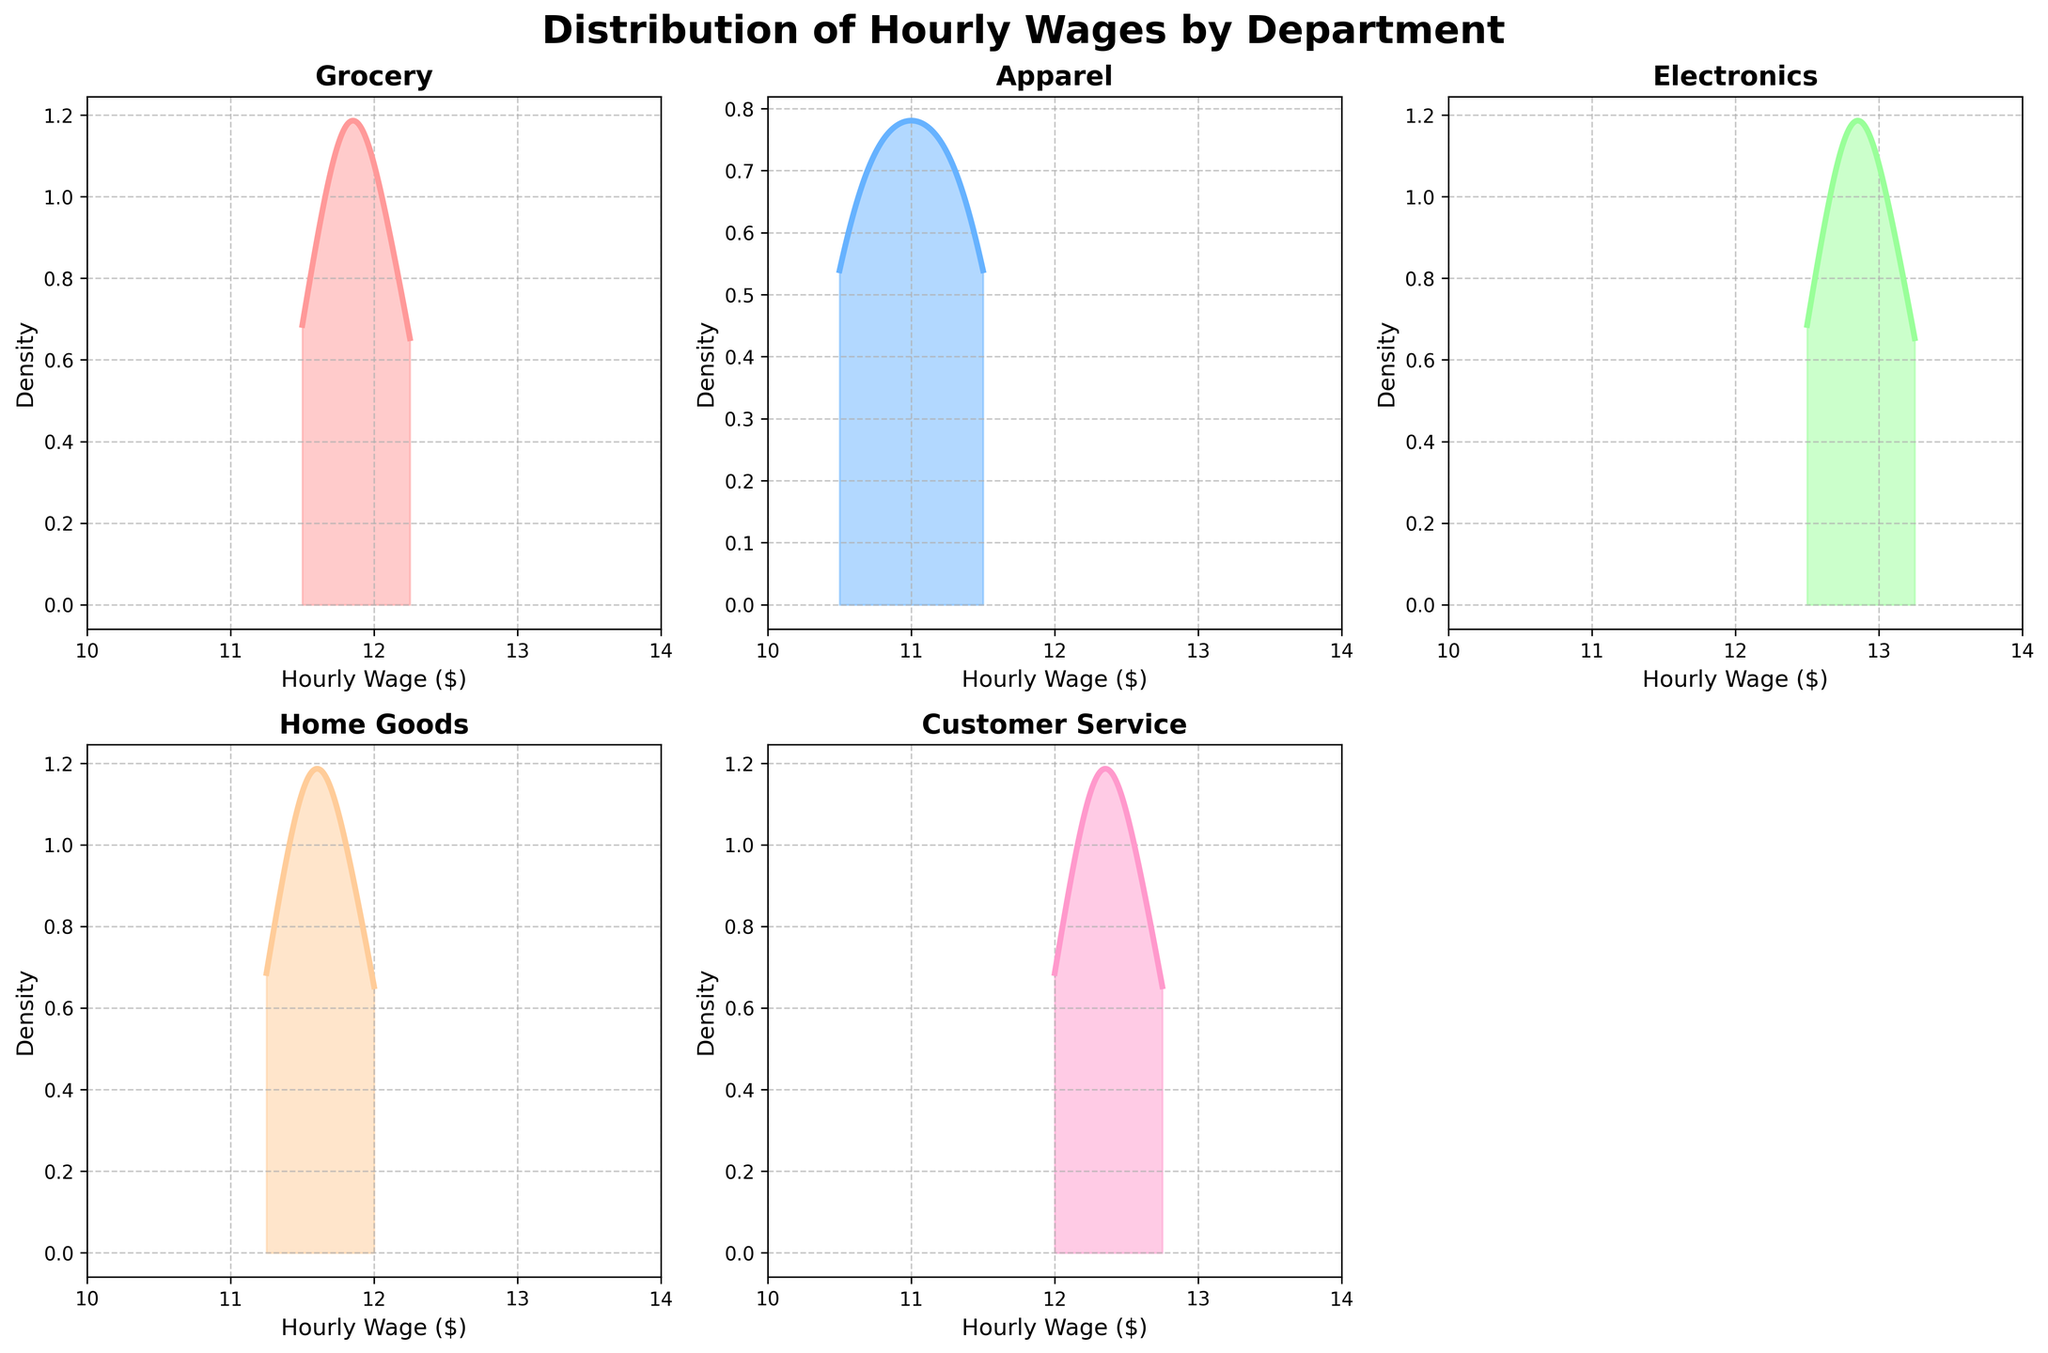What is the title of the figure? The title is located at the top of the figure and is usually written in bold or larger font size than other texts.
Answer: Distribution of Hourly Wages by Department Which department has the highest peak density in their wage distribution? Looking at the height of the peaks in each subplot, the department with the highest peak density will have the tallest line.
Answer: Electronics What is the approximate hourly wage range for the Customer Service department? Check the x-axis range of the Customer Service subplot to determine the minimum and maximum values displayed.
Answer: $12.00 - $12.75 Which department shows the widest range of hourly wages? Identify which subplot shows the most spread out density curve along the x-axis. This will indicate the department with the widest range of hourly wages.
Answer: Apparel How does the wage distribution for Home Goods compare to that of Grocery? Compare the shapes and spread of the density curves in the Home Goods and Grocery subplots.
Answer: Home Goods has a slightly broader and more even distribution, while Grocery is more concentrated What is the color used for the Apparel department's density plot? Observe the color fill and line in the subplot labeled "Apparel".
Answer: Blue Which department has most of its wage distribution centered around the lowest value in the range? Look for the department where the peak of the density plot is closest to the lowest value on the x-axis.
Answer: Apparel What are the x-axis and y-axis labels used in the plots? Check any subplot; they all share the same labeling for the x-axis and y-axis.
Answer: Hourly Wage ($) for x-axis and Density for y-axis Which department has the most similar wage distribution to Customer Service based on visual inspection? Compare the Customer Service subplot to other department subplots and identify which one has a similar spread and peak around similar hourly wages.
Answer: Electronics Is there any subplot with an empty axis, and if so, which one? Check if any subplot area does not contain a density plot and looks blank.
Answer: The subplot at the bottom right (axs[1, 2]) 